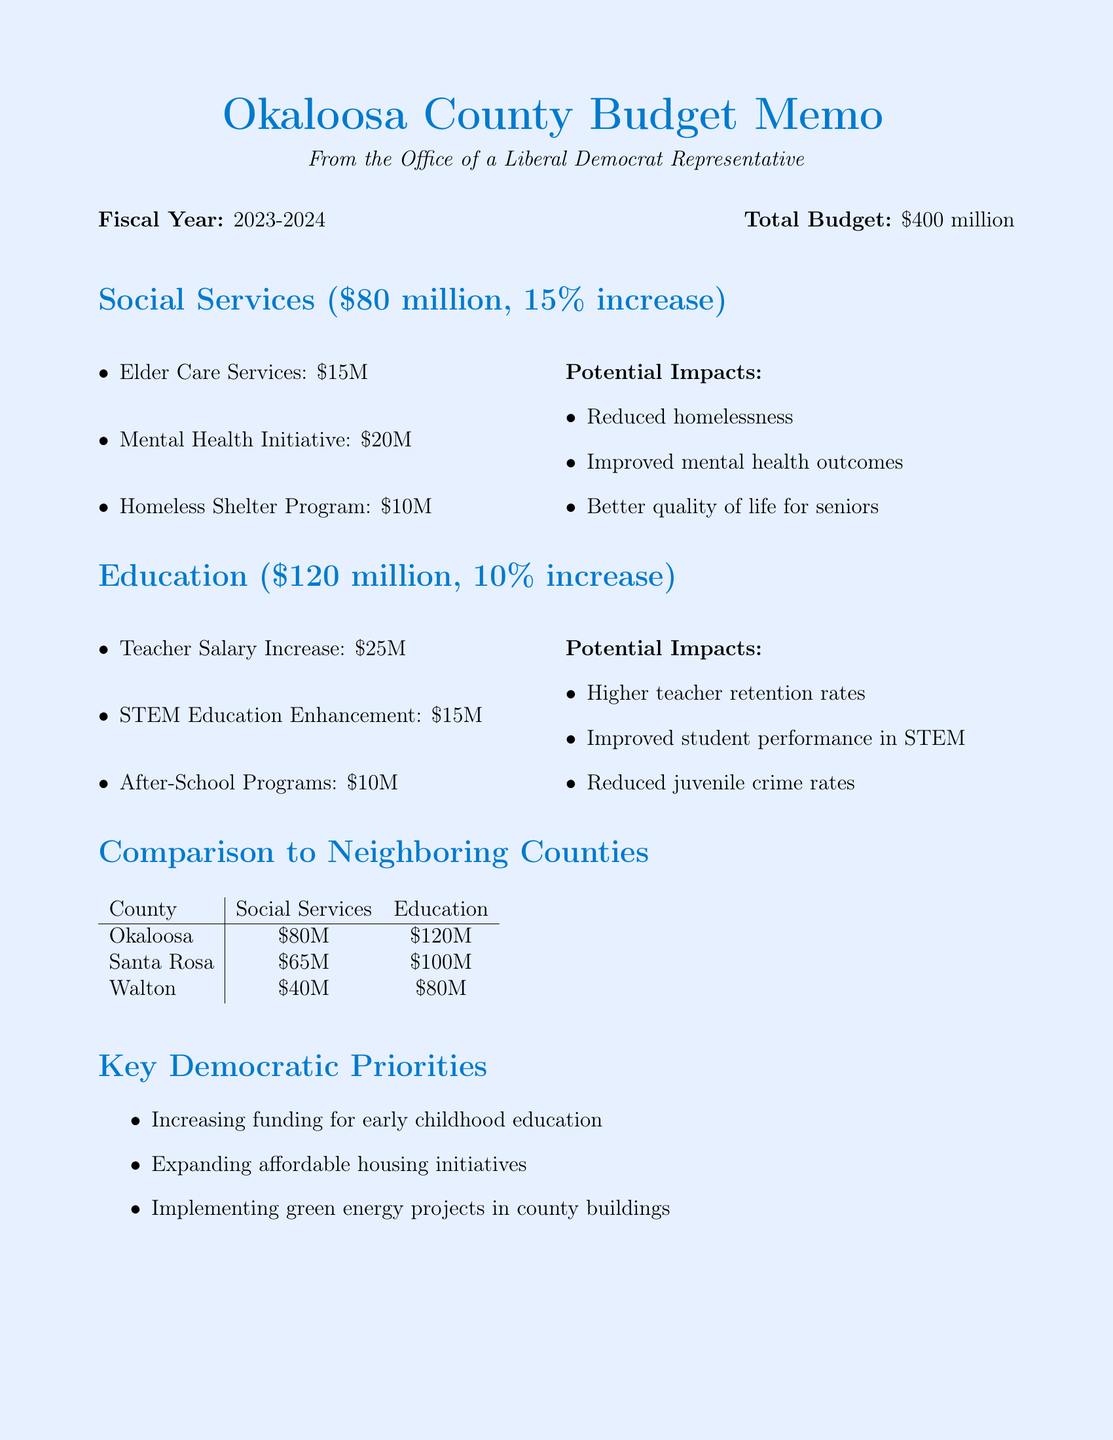What is the total budget for Okaloosa County? The total budget is stated at the beginning of the document as part of the county budget overview.
Answer: $400 million How much is allocated for social services? The total allocation for social services is provided in the section detailing social services allocation.
Answer: $80 million What is the increase percentage for education funding compared to the previous year? The increase for education funding is specified in the education allocation section.
Answer: 10% What is one of the key programs under social services? The document lists several key programs, asking for one of them reflects information retrieval about this category.
Answer: Mental Health Initiative What are two potential impacts of increased social services funding? Potential impacts are listed in the social services section, requiring synthesis of two points from that list for a complete answer.
Answer: Reduced homelessness, Improved mental health outcomes Where will one of the public forums be held? The locations of public forums are listed, and asking for one of them checks the reader's retrieval abilities.
Answer: Fort Walton Beach High School Auditorium Which neighboring county has a higher social services budget than Okaloosa? The comparison section provides data on the budgets of neighboring counties, requiring a comparison to answer this question.
Answer: Santa Rosa What is one of the key Democratic priorities mentioned in the memo? Key priorities are explicitly stated and requires retrieval from that section of the document.
Answer: Increasing funding for early childhood education 